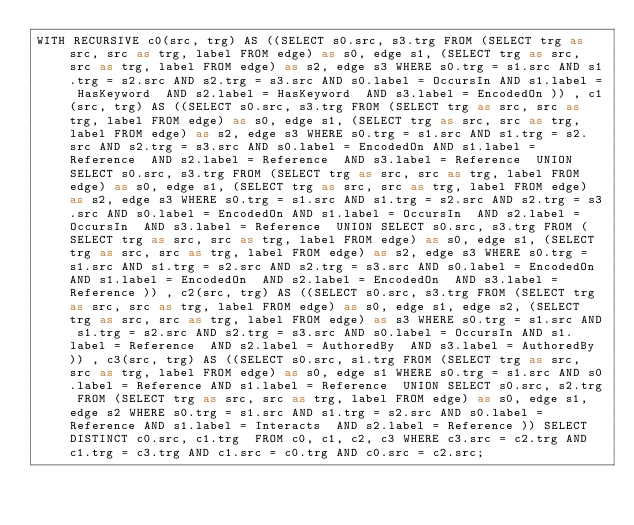<code> <loc_0><loc_0><loc_500><loc_500><_SQL_>WITH RECURSIVE c0(src, trg) AS ((SELECT s0.src, s3.trg FROM (SELECT trg as src, src as trg, label FROM edge) as s0, edge s1, (SELECT trg as src, src as trg, label FROM edge) as s2, edge s3 WHERE s0.trg = s1.src AND s1.trg = s2.src AND s2.trg = s3.src AND s0.label = OccursIn AND s1.label = HasKeyword  AND s2.label = HasKeyword  AND s3.label = EncodedOn )) , c1(src, trg) AS ((SELECT s0.src, s3.trg FROM (SELECT trg as src, src as trg, label FROM edge) as s0, edge s1, (SELECT trg as src, src as trg, label FROM edge) as s2, edge s3 WHERE s0.trg = s1.src AND s1.trg = s2.src AND s2.trg = s3.src AND s0.label = EncodedOn AND s1.label = Reference  AND s2.label = Reference  AND s3.label = Reference  UNION SELECT s0.src, s3.trg FROM (SELECT trg as src, src as trg, label FROM edge) as s0, edge s1, (SELECT trg as src, src as trg, label FROM edge) as s2, edge s3 WHERE s0.trg = s1.src AND s1.trg = s2.src AND s2.trg = s3.src AND s0.label = EncodedOn AND s1.label = OccursIn  AND s2.label = OccursIn  AND s3.label = Reference  UNION SELECT s0.src, s3.trg FROM (SELECT trg as src, src as trg, label FROM edge) as s0, edge s1, (SELECT trg as src, src as trg, label FROM edge) as s2, edge s3 WHERE s0.trg = s1.src AND s1.trg = s2.src AND s2.trg = s3.src AND s0.label = EncodedOn AND s1.label = EncodedOn  AND s2.label = EncodedOn  AND s3.label = Reference )) , c2(src, trg) AS ((SELECT s0.src, s3.trg FROM (SELECT trg as src, src as trg, label FROM edge) as s0, edge s1, edge s2, (SELECT trg as src, src as trg, label FROM edge) as s3 WHERE s0.trg = s1.src AND s1.trg = s2.src AND s2.trg = s3.src AND s0.label = OccursIn AND s1.label = Reference  AND s2.label = AuthoredBy  AND s3.label = AuthoredBy )) , c3(src, trg) AS ((SELECT s0.src, s1.trg FROM (SELECT trg as src, src as trg, label FROM edge) as s0, edge s1 WHERE s0.trg = s1.src AND s0.label = Reference AND s1.label = Reference  UNION SELECT s0.src, s2.trg FROM (SELECT trg as src, src as trg, label FROM edge) as s0, edge s1, edge s2 WHERE s0.trg = s1.src AND s1.trg = s2.src AND s0.label = Reference AND s1.label = Interacts  AND s2.label = Reference )) SELECT DISTINCT c0.src, c1.trg  FROM c0, c1, c2, c3 WHERE c3.src = c2.trg AND c1.trg = c3.trg AND c1.src = c0.trg AND c0.src = c2.src;
</code> 